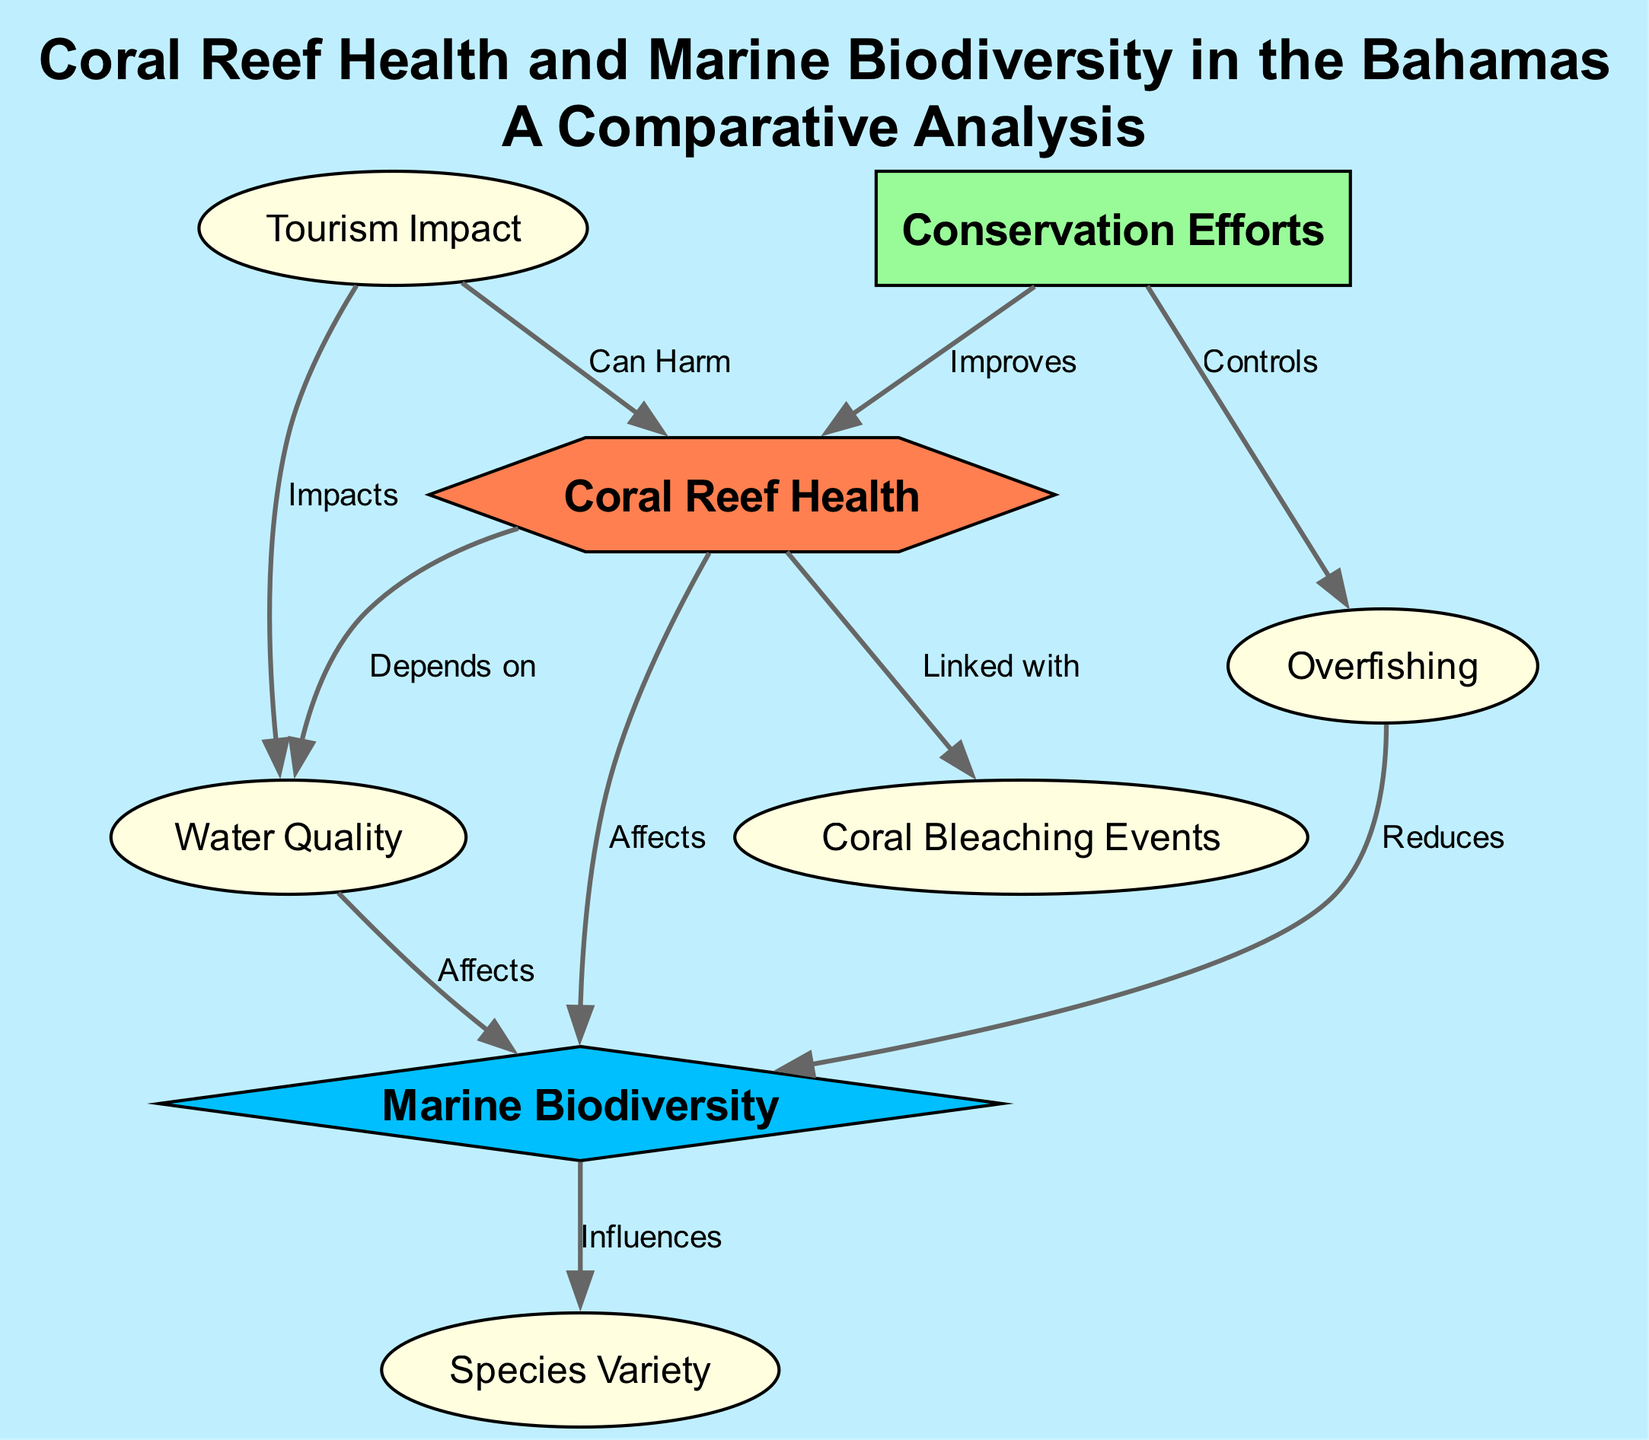What are the two main nodes highlighted in the diagram? The two main nodes, or focal points, in this diagram are "Coral Reef Health" and "Marine Biodiversity." They are represented prominently and serve as the main subjects of the analysis.
Answer: Coral Reef Health, Marine Biodiversity How many edges are connecting to the node "Coral Reef Health"? There are three edges connecting to the node "Coral Reef Health." These edges show relationships to "Marine Biodiversity," "Coral Bleaching Events," and "Water Quality."
Answer: 3 What does the edge from "Coral Reef Health" to "Marine Biodiversity" indicate? The edge labeled "Affects" connecting "Coral Reef Health" to "Marine Biodiversity" indicates that the health of coral reefs impacts the biodiversity of marine life.
Answer: Affects How does "Water Quality" impact "Marine Biodiversity"? The edge labeled "Affects" shows that "Water Quality" directly influences "Marine Biodiversity," meaning that improvements in water quality can lead to better marine biodiversity.
Answer: Affects What is the relationship between "Tourism Impact" and "Coral Reef Health"? The edge labeled "Can Harm" shows that "Tourism Impact" can negatively affect the health of coral reefs, suggesting that tourism activities may lead to degradation.
Answer: Can Harm Which node represents an action that controls another factor related to coral reefs? "Conservation Efforts" is the node that indicates an action, as it controls "Overfishing," highlighting its role in managing that aspect for better coral health.
Answer: Conservation Efforts What effect does "Overfishing" have on "Marine Biodiversity"? The edge connecting "Overfishing" to "Marine Biodiversity" is labeled "Reduces," which indicates that overfishing leads to a decrease in marine biodiversity.
Answer: Reduces How does "Coral Bleaching Events" relate to "Coral Reef Health"? The edge labeled "Linked with" shows that "Coral Bleaching Events" are associated with "Coral Reef Health," indicating that the health of coral reefs may influence the occurrence of bleaching.
Answer: Linked with 